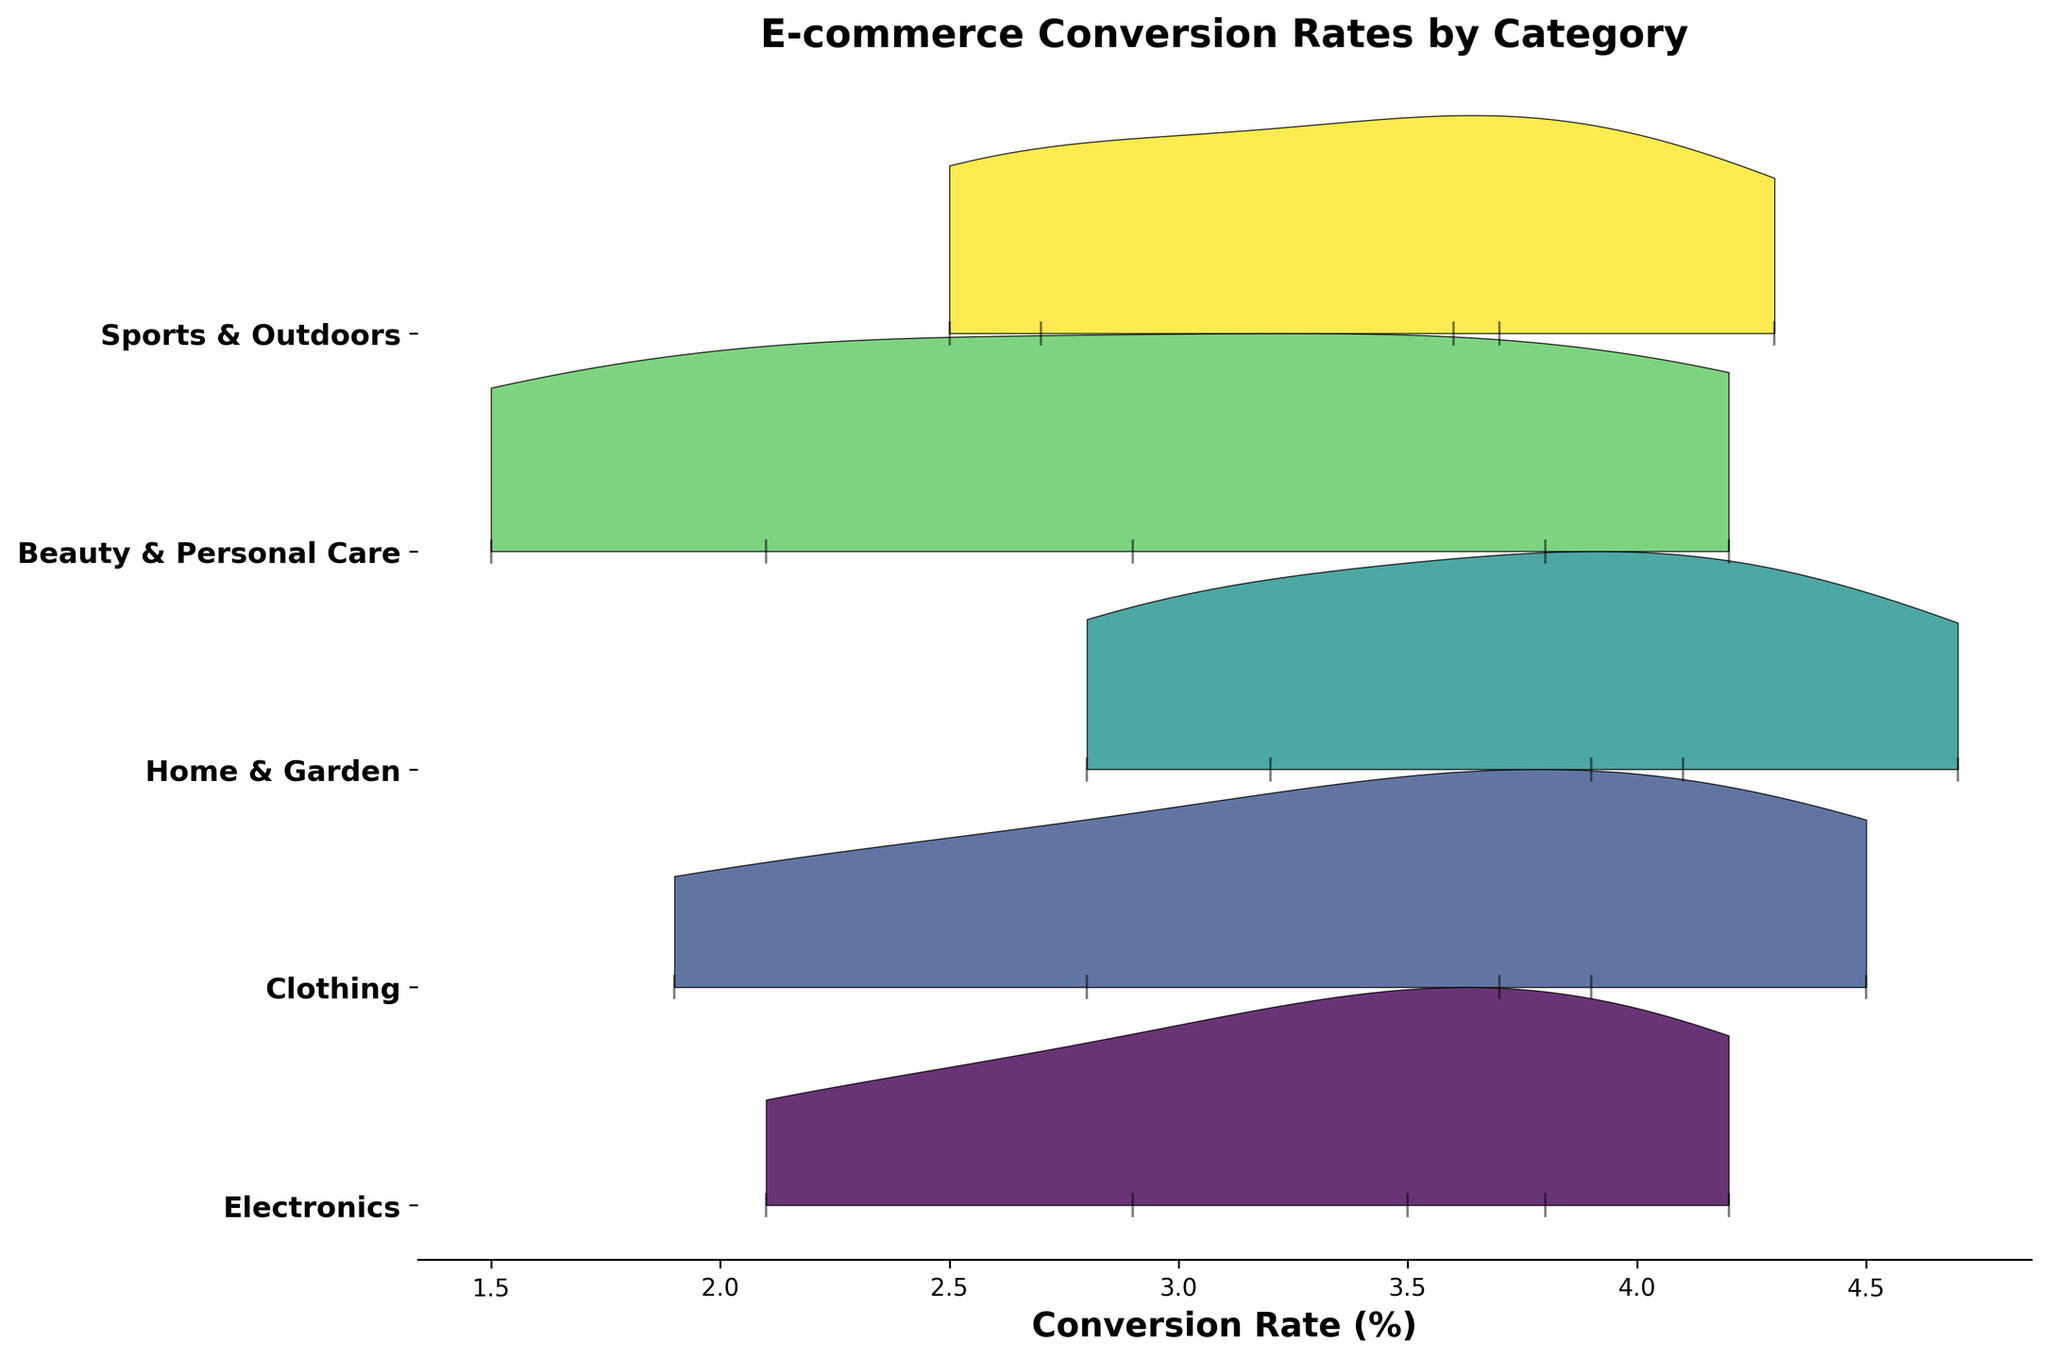Which category has the highest average conversion rate? By observing the peaks of the ridgelines, we can identify the highest average conversion rate. The "Home & Garden" category appears to have the highest peak.
Answer: Home & Garden What is the range of conversion rates for the "Electronics" category? The conversion rates for the "Electronics" category range from the lowest value to the highest value presented. The range is from 2.1% to 4.2%.
Answer: 2.1% - 4.2% When considering price points above $501, which category shows the highest conversion rate? By inspecting the ridgelines for price points above $501, "Home & Garden" exhibits the highest conversion rate.
Answer: Home & Garden Which category has the lowest conversion rate at the $0-$50 price range? Visual inspection of the ridgelines at the $0-$50 price range indicates that "Electronics" has the lowest conversion rate.
Answer: Electronics How does the conversion rate trend generally change for the "Beauty & Personal Care" category as price increases? Examining the "Beauty & Personal Care" ridgeline, we observe a general decrease in conversion rates as the price increases.
Answer: Decreases For the price range $201-$500, which category shows the highest conversion rate? Analyzing the corresponding ridgelines, "Home & Garden" shows the highest conversion rate in this price range.
Answer: Home & Garden Are there any anomalies in conversion rates within categories, such as a peak that does not follow the trend of surrounding price ranges? One anomaly is present in "Clothing," where the conversion rate in the $51-$200 range is higher than in the $0-$50 and $201-$500 ranges.
Answer: Clothing Which category has the most stable conversion rates across all price points? By observing the width and height of the ridgelines, "Sports & Outdoors" exhibits a relatively stable conversion rate across all price points.
Answer: Sports & Outdoors What is the conversion rate for "Clothing" in the $1001+ price range? The ridgeline for "Clothing" in the $1001+ price range shows a conversion rate of 1.9%.
Answer: 1.9% Compare the conversion rates of "Home & Garden" and "Electronics" in the $201-$500 price range. Which is higher? The conversion rate for "Home & Garden" in the $201-$500 price range is higher compared to "Electronics."
Answer: Home & Garden 